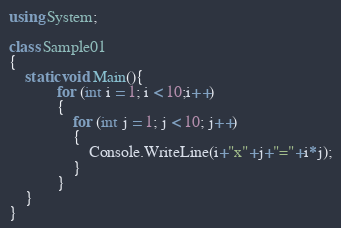Convert code to text. <code><loc_0><loc_0><loc_500><loc_500><_C#_>using System;

class Sample01
{
    static void Main(){
            for (int i = 1; i < 10;i++)
            {
                for (int j = 1; j < 10; j++)
                {
                    Console.WriteLine(i+"x"+j+"="+i*j);
                }
            }
    }
}
</code> 